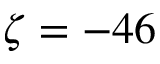Convert formula to latex. <formula><loc_0><loc_0><loc_500><loc_500>\zeta = - 4 6</formula> 